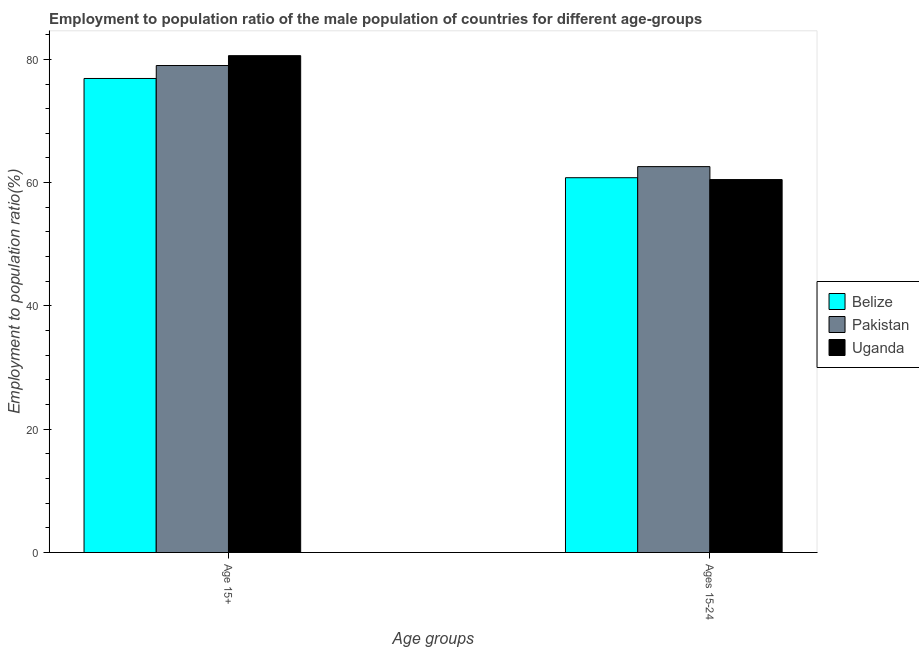How many groups of bars are there?
Ensure brevity in your answer.  2. Are the number of bars on each tick of the X-axis equal?
Your response must be concise. Yes. How many bars are there on the 1st tick from the right?
Offer a very short reply. 3. What is the label of the 2nd group of bars from the left?
Offer a very short reply. Ages 15-24. What is the employment to population ratio(age 15+) in Uganda?
Give a very brief answer. 80.6. Across all countries, what is the maximum employment to population ratio(age 15-24)?
Your response must be concise. 62.6. Across all countries, what is the minimum employment to population ratio(age 15+)?
Give a very brief answer. 76.9. In which country was the employment to population ratio(age 15-24) maximum?
Keep it short and to the point. Pakistan. In which country was the employment to population ratio(age 15+) minimum?
Your answer should be very brief. Belize. What is the total employment to population ratio(age 15+) in the graph?
Provide a short and direct response. 236.5. What is the difference between the employment to population ratio(age 15+) in Pakistan and that in Belize?
Your response must be concise. 2.1. What is the difference between the employment to population ratio(age 15+) in Belize and the employment to population ratio(age 15-24) in Pakistan?
Give a very brief answer. 14.3. What is the average employment to population ratio(age 15-24) per country?
Make the answer very short. 61.3. What is the difference between the employment to population ratio(age 15-24) and employment to population ratio(age 15+) in Uganda?
Offer a very short reply. -20.1. What is the ratio of the employment to population ratio(age 15+) in Pakistan to that in Belize?
Your answer should be very brief. 1.03. Is the employment to population ratio(age 15-24) in Uganda less than that in Pakistan?
Provide a short and direct response. Yes. In how many countries, is the employment to population ratio(age 15+) greater than the average employment to population ratio(age 15+) taken over all countries?
Your response must be concise. 2. What does the 3rd bar from the left in Ages 15-24 represents?
Offer a very short reply. Uganda. What does the 3rd bar from the right in Ages 15-24 represents?
Your response must be concise. Belize. Are all the bars in the graph horizontal?
Provide a short and direct response. No. Does the graph contain any zero values?
Your response must be concise. No. Where does the legend appear in the graph?
Keep it short and to the point. Center right. What is the title of the graph?
Your answer should be compact. Employment to population ratio of the male population of countries for different age-groups. What is the label or title of the X-axis?
Provide a succinct answer. Age groups. What is the Employment to population ratio(%) in Belize in Age 15+?
Offer a terse response. 76.9. What is the Employment to population ratio(%) of Pakistan in Age 15+?
Ensure brevity in your answer.  79. What is the Employment to population ratio(%) of Uganda in Age 15+?
Your answer should be very brief. 80.6. What is the Employment to population ratio(%) in Belize in Ages 15-24?
Provide a short and direct response. 60.8. What is the Employment to population ratio(%) in Pakistan in Ages 15-24?
Your answer should be very brief. 62.6. What is the Employment to population ratio(%) of Uganda in Ages 15-24?
Ensure brevity in your answer.  60.5. Across all Age groups, what is the maximum Employment to population ratio(%) of Belize?
Provide a short and direct response. 76.9. Across all Age groups, what is the maximum Employment to population ratio(%) of Pakistan?
Your answer should be compact. 79. Across all Age groups, what is the maximum Employment to population ratio(%) of Uganda?
Offer a very short reply. 80.6. Across all Age groups, what is the minimum Employment to population ratio(%) in Belize?
Provide a short and direct response. 60.8. Across all Age groups, what is the minimum Employment to population ratio(%) of Pakistan?
Your response must be concise. 62.6. Across all Age groups, what is the minimum Employment to population ratio(%) of Uganda?
Give a very brief answer. 60.5. What is the total Employment to population ratio(%) in Belize in the graph?
Provide a succinct answer. 137.7. What is the total Employment to population ratio(%) in Pakistan in the graph?
Ensure brevity in your answer.  141.6. What is the total Employment to population ratio(%) of Uganda in the graph?
Your response must be concise. 141.1. What is the difference between the Employment to population ratio(%) in Pakistan in Age 15+ and that in Ages 15-24?
Your answer should be compact. 16.4. What is the difference between the Employment to population ratio(%) of Uganda in Age 15+ and that in Ages 15-24?
Your answer should be very brief. 20.1. What is the difference between the Employment to population ratio(%) in Belize in Age 15+ and the Employment to population ratio(%) in Pakistan in Ages 15-24?
Ensure brevity in your answer.  14.3. What is the difference between the Employment to population ratio(%) in Belize in Age 15+ and the Employment to population ratio(%) in Uganda in Ages 15-24?
Offer a terse response. 16.4. What is the difference between the Employment to population ratio(%) of Pakistan in Age 15+ and the Employment to population ratio(%) of Uganda in Ages 15-24?
Offer a terse response. 18.5. What is the average Employment to population ratio(%) in Belize per Age groups?
Your response must be concise. 68.85. What is the average Employment to population ratio(%) in Pakistan per Age groups?
Your answer should be very brief. 70.8. What is the average Employment to population ratio(%) of Uganda per Age groups?
Offer a very short reply. 70.55. What is the difference between the Employment to population ratio(%) of Belize and Employment to population ratio(%) of Pakistan in Age 15+?
Offer a very short reply. -2.1. What is the difference between the Employment to population ratio(%) in Belize and Employment to population ratio(%) in Uganda in Age 15+?
Provide a succinct answer. -3.7. What is the difference between the Employment to population ratio(%) of Pakistan and Employment to population ratio(%) of Uganda in Age 15+?
Your answer should be compact. -1.6. What is the difference between the Employment to population ratio(%) of Belize and Employment to population ratio(%) of Pakistan in Ages 15-24?
Provide a short and direct response. -1.8. What is the difference between the Employment to population ratio(%) of Belize and Employment to population ratio(%) of Uganda in Ages 15-24?
Make the answer very short. 0.3. What is the ratio of the Employment to population ratio(%) in Belize in Age 15+ to that in Ages 15-24?
Your answer should be compact. 1.26. What is the ratio of the Employment to population ratio(%) in Pakistan in Age 15+ to that in Ages 15-24?
Your answer should be compact. 1.26. What is the ratio of the Employment to population ratio(%) of Uganda in Age 15+ to that in Ages 15-24?
Offer a terse response. 1.33. What is the difference between the highest and the second highest Employment to population ratio(%) in Pakistan?
Ensure brevity in your answer.  16.4. What is the difference between the highest and the second highest Employment to population ratio(%) in Uganda?
Provide a succinct answer. 20.1. What is the difference between the highest and the lowest Employment to population ratio(%) in Belize?
Provide a short and direct response. 16.1. What is the difference between the highest and the lowest Employment to population ratio(%) of Pakistan?
Your answer should be very brief. 16.4. What is the difference between the highest and the lowest Employment to population ratio(%) in Uganda?
Provide a short and direct response. 20.1. 